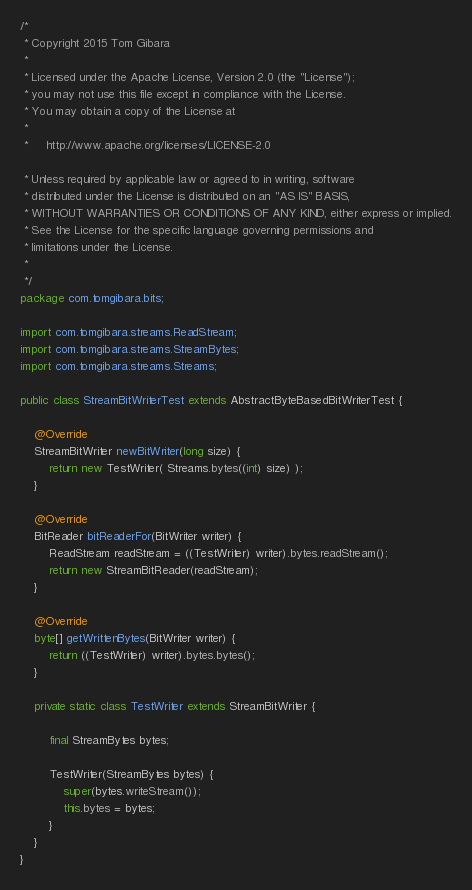<code> <loc_0><loc_0><loc_500><loc_500><_Java_>/*
 * Copyright 2015 Tom Gibara
 *
 * Licensed under the Apache License, Version 2.0 (the "License");
 * you may not use this file except in compliance with the License.
 * You may obtain a copy of the License at
 *
 *     http://www.apache.org/licenses/LICENSE-2.0

 * Unless required by applicable law or agreed to in writing, software
 * distributed under the License is distributed on an "AS IS" BASIS,
 * WITHOUT WARRANTIES OR CONDITIONS OF ANY KIND, either express or implied.
 * See the License for the specific language governing permissions and
 * limitations under the License.
 *
 */
package com.tomgibara.bits;

import com.tomgibara.streams.ReadStream;
import com.tomgibara.streams.StreamBytes;
import com.tomgibara.streams.Streams;

public class StreamBitWriterTest extends AbstractByteBasedBitWriterTest {

	@Override
	StreamBitWriter newBitWriter(long size) {
		return new TestWriter( Streams.bytes((int) size) );
	}

	@Override
	BitReader bitReaderFor(BitWriter writer) {
		ReadStream readStream = ((TestWriter) writer).bytes.readStream();
		return new StreamBitReader(readStream);
	}

	@Override
	byte[] getWrittenBytes(BitWriter writer) {
		return ((TestWriter) writer).bytes.bytes();
	}

	private static class TestWriter extends StreamBitWriter {

		final StreamBytes bytes;

		TestWriter(StreamBytes bytes) {
			super(bytes.writeStream());
			this.bytes = bytes;
		}
	}
}
</code> 